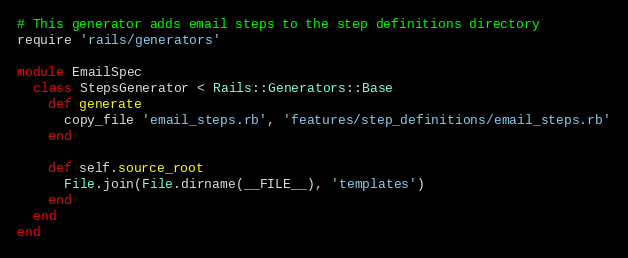<code> <loc_0><loc_0><loc_500><loc_500><_Ruby_># This generator adds email steps to the step definitions directory
require 'rails/generators'

module EmailSpec
  class StepsGenerator < Rails::Generators::Base
    def generate
      copy_file 'email_steps.rb', 'features/step_definitions/email_steps.rb'
    end

    def self.source_root
      File.join(File.dirname(__FILE__), 'templates')
    end
  end
end</code> 